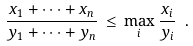Convert formula to latex. <formula><loc_0><loc_0><loc_500><loc_500>\frac { x _ { 1 } + \cdots + x _ { n } } { y _ { 1 } + \cdots + y _ { n } } \, \leq \, \max _ { i } \frac { x _ { i } } { y _ { i } } \ .</formula> 